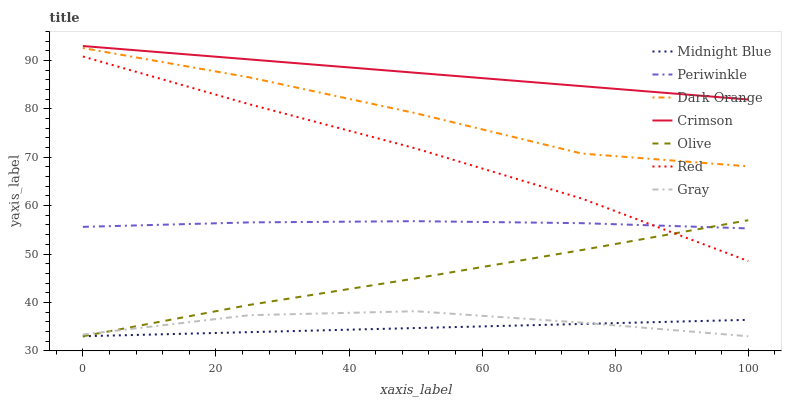Does Midnight Blue have the minimum area under the curve?
Answer yes or no. Yes. Does Crimson have the maximum area under the curve?
Answer yes or no. Yes. Does Gray have the minimum area under the curve?
Answer yes or no. No. Does Gray have the maximum area under the curve?
Answer yes or no. No. Is Midnight Blue the smoothest?
Answer yes or no. Yes. Is Dark Orange the roughest?
Answer yes or no. Yes. Is Gray the smoothest?
Answer yes or no. No. Is Gray the roughest?
Answer yes or no. No. Does Periwinkle have the lowest value?
Answer yes or no. No. Does Crimson have the highest value?
Answer yes or no. Yes. Does Gray have the highest value?
Answer yes or no. No. Is Red less than Crimson?
Answer yes or no. Yes. Is Crimson greater than Periwinkle?
Answer yes or no. Yes. Does Red intersect Crimson?
Answer yes or no. No. 